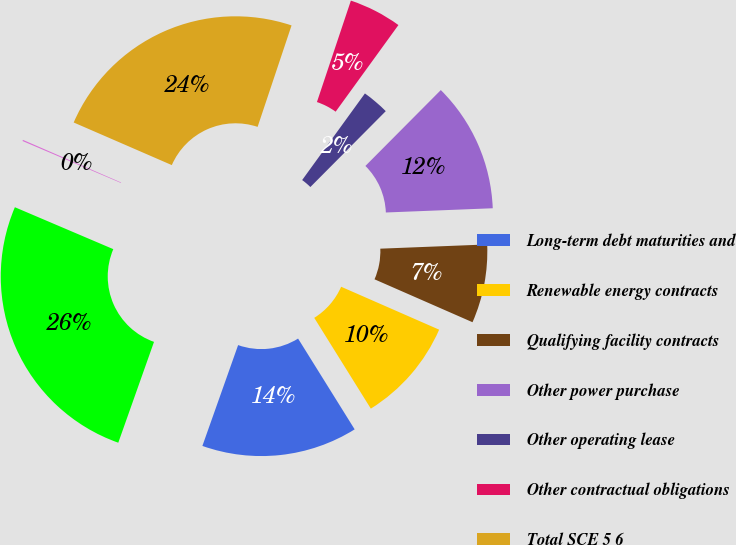Convert chart. <chart><loc_0><loc_0><loc_500><loc_500><pie_chart><fcel>Long-term debt maturities and<fcel>Renewable energy contracts<fcel>Qualifying facility contracts<fcel>Other power purchase<fcel>Other operating lease<fcel>Other contractual obligations<fcel>Total SCE 5 6<fcel>Total Edison International<fcel>Total Edison International 67<nl><fcel>14.29%<fcel>9.56%<fcel>7.2%<fcel>11.92%<fcel>2.47%<fcel>4.84%<fcel>23.62%<fcel>0.11%<fcel>25.99%<nl></chart> 